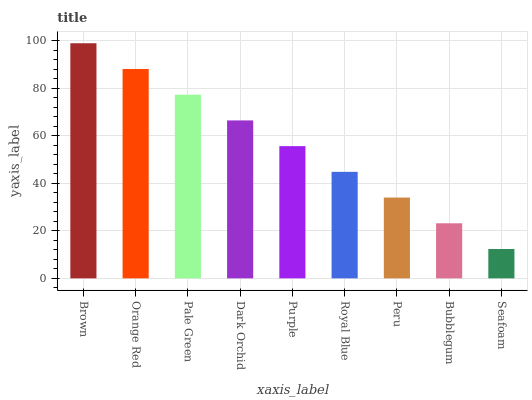Is Seafoam the minimum?
Answer yes or no. Yes. Is Brown the maximum?
Answer yes or no. Yes. Is Orange Red the minimum?
Answer yes or no. No. Is Orange Red the maximum?
Answer yes or no. No. Is Brown greater than Orange Red?
Answer yes or no. Yes. Is Orange Red less than Brown?
Answer yes or no. Yes. Is Orange Red greater than Brown?
Answer yes or no. No. Is Brown less than Orange Red?
Answer yes or no. No. Is Purple the high median?
Answer yes or no. Yes. Is Purple the low median?
Answer yes or no. Yes. Is Orange Red the high median?
Answer yes or no. No. Is Dark Orchid the low median?
Answer yes or no. No. 